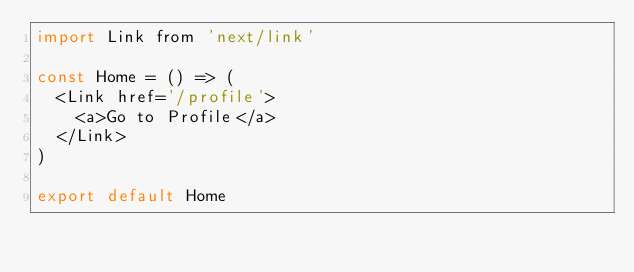<code> <loc_0><loc_0><loc_500><loc_500><_JavaScript_>import Link from 'next/link'

const Home = () => (
  <Link href='/profile'>
    <a>Go to Profile</a>
  </Link>
)

export default Home</code> 